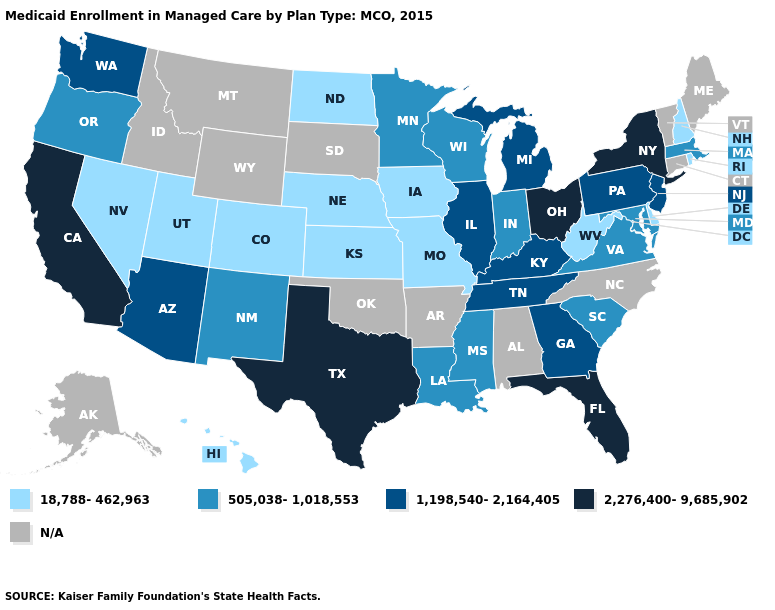Does Florida have the lowest value in the USA?
Answer briefly. No. Name the states that have a value in the range 2,276,400-9,685,902?
Be succinct. California, Florida, New York, Ohio, Texas. Does Tennessee have the lowest value in the USA?
Keep it brief. No. What is the value of Arkansas?
Answer briefly. N/A. What is the lowest value in the Northeast?
Write a very short answer. 18,788-462,963. Name the states that have a value in the range 505,038-1,018,553?
Give a very brief answer. Indiana, Louisiana, Maryland, Massachusetts, Minnesota, Mississippi, New Mexico, Oregon, South Carolina, Virginia, Wisconsin. Name the states that have a value in the range 1,198,540-2,164,405?
Short answer required. Arizona, Georgia, Illinois, Kentucky, Michigan, New Jersey, Pennsylvania, Tennessee, Washington. What is the lowest value in the USA?
Answer briefly. 18,788-462,963. Name the states that have a value in the range N/A?
Short answer required. Alabama, Alaska, Arkansas, Connecticut, Idaho, Maine, Montana, North Carolina, Oklahoma, South Dakota, Vermont, Wyoming. Which states have the lowest value in the USA?
Write a very short answer. Colorado, Delaware, Hawaii, Iowa, Kansas, Missouri, Nebraska, Nevada, New Hampshire, North Dakota, Rhode Island, Utah, West Virginia. Does North Dakota have the lowest value in the USA?
Keep it brief. Yes. Name the states that have a value in the range 505,038-1,018,553?
Give a very brief answer. Indiana, Louisiana, Maryland, Massachusetts, Minnesota, Mississippi, New Mexico, Oregon, South Carolina, Virginia, Wisconsin. What is the value of Oregon?
Answer briefly. 505,038-1,018,553. Is the legend a continuous bar?
Give a very brief answer. No. 